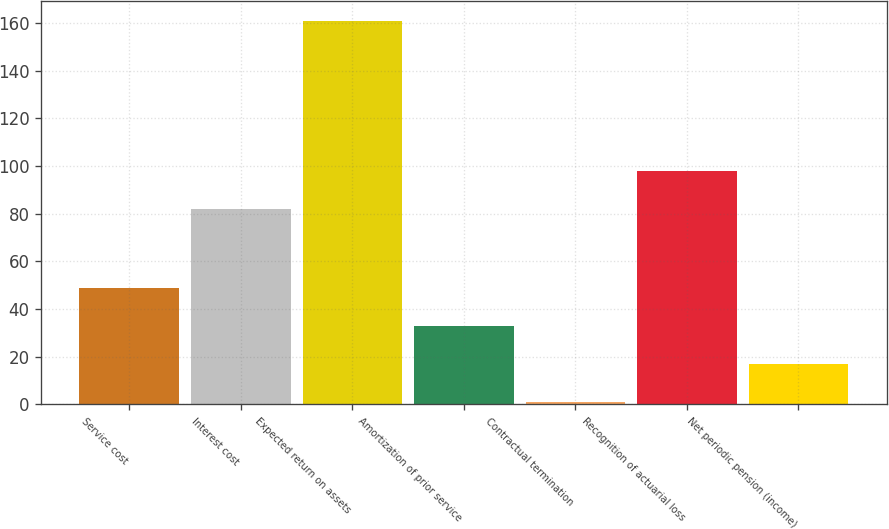Convert chart to OTSL. <chart><loc_0><loc_0><loc_500><loc_500><bar_chart><fcel>Service cost<fcel>Interest cost<fcel>Expected return on assets<fcel>Amortization of prior service<fcel>Contractual termination<fcel>Recognition of actuarial loss<fcel>Net periodic pension (income)<nl><fcel>49<fcel>82<fcel>161<fcel>33<fcel>1<fcel>98<fcel>17<nl></chart> 